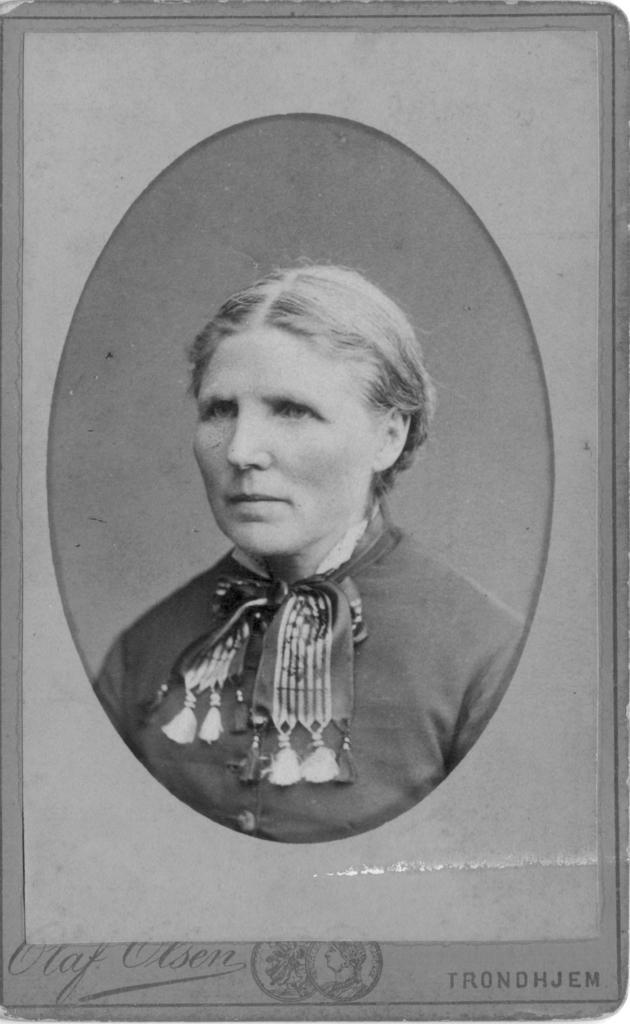Can you describe this image briefly? As we can see in the image there is a woman wearing black color dress. 